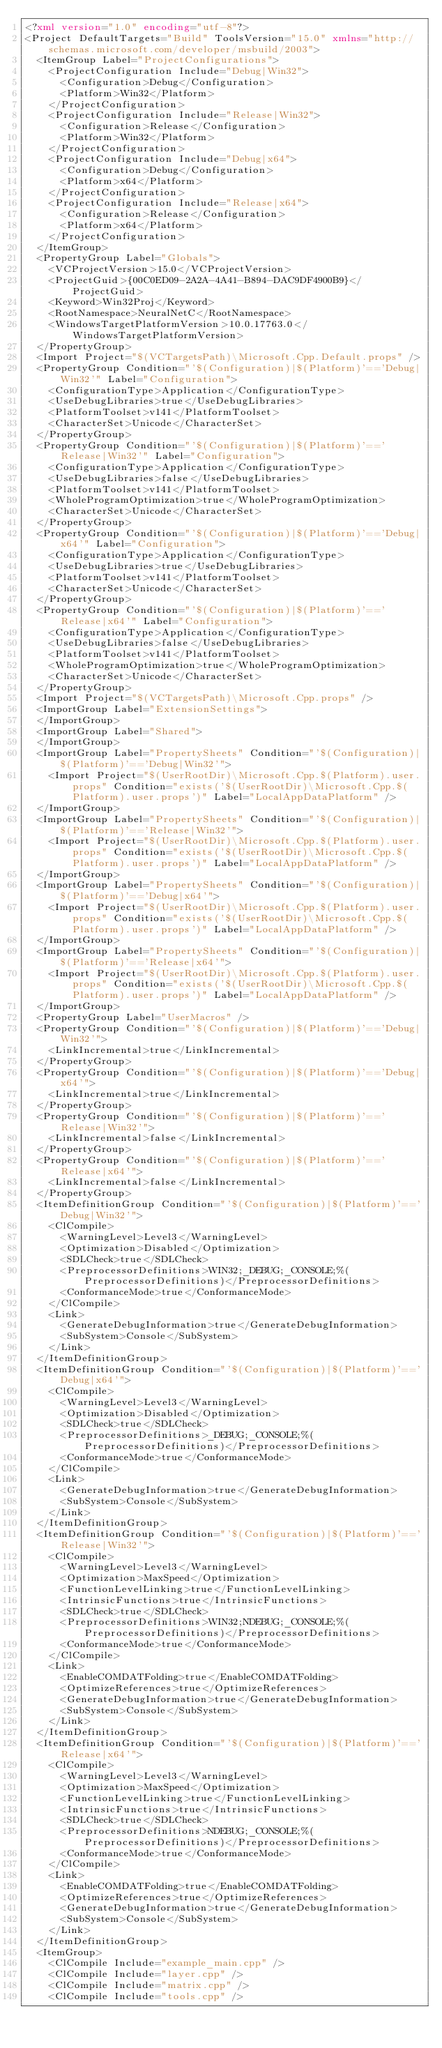<code> <loc_0><loc_0><loc_500><loc_500><_XML_><?xml version="1.0" encoding="utf-8"?>
<Project DefaultTargets="Build" ToolsVersion="15.0" xmlns="http://schemas.microsoft.com/developer/msbuild/2003">
  <ItemGroup Label="ProjectConfigurations">
    <ProjectConfiguration Include="Debug|Win32">
      <Configuration>Debug</Configuration>
      <Platform>Win32</Platform>
    </ProjectConfiguration>
    <ProjectConfiguration Include="Release|Win32">
      <Configuration>Release</Configuration>
      <Platform>Win32</Platform>
    </ProjectConfiguration>
    <ProjectConfiguration Include="Debug|x64">
      <Configuration>Debug</Configuration>
      <Platform>x64</Platform>
    </ProjectConfiguration>
    <ProjectConfiguration Include="Release|x64">
      <Configuration>Release</Configuration>
      <Platform>x64</Platform>
    </ProjectConfiguration>
  </ItemGroup>
  <PropertyGroup Label="Globals">
    <VCProjectVersion>15.0</VCProjectVersion>
    <ProjectGuid>{00C0ED09-2A2A-4A41-B894-DAC9DF4900B9}</ProjectGuid>
    <Keyword>Win32Proj</Keyword>
    <RootNamespace>NeuralNetC</RootNamespace>
    <WindowsTargetPlatformVersion>10.0.17763.0</WindowsTargetPlatformVersion>
  </PropertyGroup>
  <Import Project="$(VCTargetsPath)\Microsoft.Cpp.Default.props" />
  <PropertyGroup Condition="'$(Configuration)|$(Platform)'=='Debug|Win32'" Label="Configuration">
    <ConfigurationType>Application</ConfigurationType>
    <UseDebugLibraries>true</UseDebugLibraries>
    <PlatformToolset>v141</PlatformToolset>
    <CharacterSet>Unicode</CharacterSet>
  </PropertyGroup>
  <PropertyGroup Condition="'$(Configuration)|$(Platform)'=='Release|Win32'" Label="Configuration">
    <ConfigurationType>Application</ConfigurationType>
    <UseDebugLibraries>false</UseDebugLibraries>
    <PlatformToolset>v141</PlatformToolset>
    <WholeProgramOptimization>true</WholeProgramOptimization>
    <CharacterSet>Unicode</CharacterSet>
  </PropertyGroup>
  <PropertyGroup Condition="'$(Configuration)|$(Platform)'=='Debug|x64'" Label="Configuration">
    <ConfigurationType>Application</ConfigurationType>
    <UseDebugLibraries>true</UseDebugLibraries>
    <PlatformToolset>v141</PlatformToolset>
    <CharacterSet>Unicode</CharacterSet>
  </PropertyGroup>
  <PropertyGroup Condition="'$(Configuration)|$(Platform)'=='Release|x64'" Label="Configuration">
    <ConfigurationType>Application</ConfigurationType>
    <UseDebugLibraries>false</UseDebugLibraries>
    <PlatformToolset>v141</PlatformToolset>
    <WholeProgramOptimization>true</WholeProgramOptimization>
    <CharacterSet>Unicode</CharacterSet>
  </PropertyGroup>
  <Import Project="$(VCTargetsPath)\Microsoft.Cpp.props" />
  <ImportGroup Label="ExtensionSettings">
  </ImportGroup>
  <ImportGroup Label="Shared">
  </ImportGroup>
  <ImportGroup Label="PropertySheets" Condition="'$(Configuration)|$(Platform)'=='Debug|Win32'">
    <Import Project="$(UserRootDir)\Microsoft.Cpp.$(Platform).user.props" Condition="exists('$(UserRootDir)\Microsoft.Cpp.$(Platform).user.props')" Label="LocalAppDataPlatform" />
  </ImportGroup>
  <ImportGroup Label="PropertySheets" Condition="'$(Configuration)|$(Platform)'=='Release|Win32'">
    <Import Project="$(UserRootDir)\Microsoft.Cpp.$(Platform).user.props" Condition="exists('$(UserRootDir)\Microsoft.Cpp.$(Platform).user.props')" Label="LocalAppDataPlatform" />
  </ImportGroup>
  <ImportGroup Label="PropertySheets" Condition="'$(Configuration)|$(Platform)'=='Debug|x64'">
    <Import Project="$(UserRootDir)\Microsoft.Cpp.$(Platform).user.props" Condition="exists('$(UserRootDir)\Microsoft.Cpp.$(Platform).user.props')" Label="LocalAppDataPlatform" />
  </ImportGroup>
  <ImportGroup Label="PropertySheets" Condition="'$(Configuration)|$(Platform)'=='Release|x64'">
    <Import Project="$(UserRootDir)\Microsoft.Cpp.$(Platform).user.props" Condition="exists('$(UserRootDir)\Microsoft.Cpp.$(Platform).user.props')" Label="LocalAppDataPlatform" />
  </ImportGroup>
  <PropertyGroup Label="UserMacros" />
  <PropertyGroup Condition="'$(Configuration)|$(Platform)'=='Debug|Win32'">
    <LinkIncremental>true</LinkIncremental>
  </PropertyGroup>
  <PropertyGroup Condition="'$(Configuration)|$(Platform)'=='Debug|x64'">
    <LinkIncremental>true</LinkIncremental>
  </PropertyGroup>
  <PropertyGroup Condition="'$(Configuration)|$(Platform)'=='Release|Win32'">
    <LinkIncremental>false</LinkIncremental>
  </PropertyGroup>
  <PropertyGroup Condition="'$(Configuration)|$(Platform)'=='Release|x64'">
    <LinkIncremental>false</LinkIncremental>
  </PropertyGroup>
  <ItemDefinitionGroup Condition="'$(Configuration)|$(Platform)'=='Debug|Win32'">
    <ClCompile>
      <WarningLevel>Level3</WarningLevel>
      <Optimization>Disabled</Optimization>
      <SDLCheck>true</SDLCheck>
      <PreprocessorDefinitions>WIN32;_DEBUG;_CONSOLE;%(PreprocessorDefinitions)</PreprocessorDefinitions>
      <ConformanceMode>true</ConformanceMode>
    </ClCompile>
    <Link>
      <GenerateDebugInformation>true</GenerateDebugInformation>
      <SubSystem>Console</SubSystem>
    </Link>
  </ItemDefinitionGroup>
  <ItemDefinitionGroup Condition="'$(Configuration)|$(Platform)'=='Debug|x64'">
    <ClCompile>
      <WarningLevel>Level3</WarningLevel>
      <Optimization>Disabled</Optimization>
      <SDLCheck>true</SDLCheck>
      <PreprocessorDefinitions>_DEBUG;_CONSOLE;%(PreprocessorDefinitions)</PreprocessorDefinitions>
      <ConformanceMode>true</ConformanceMode>
    </ClCompile>
    <Link>
      <GenerateDebugInformation>true</GenerateDebugInformation>
      <SubSystem>Console</SubSystem>
    </Link>
  </ItemDefinitionGroup>
  <ItemDefinitionGroup Condition="'$(Configuration)|$(Platform)'=='Release|Win32'">
    <ClCompile>
      <WarningLevel>Level3</WarningLevel>
      <Optimization>MaxSpeed</Optimization>
      <FunctionLevelLinking>true</FunctionLevelLinking>
      <IntrinsicFunctions>true</IntrinsicFunctions>
      <SDLCheck>true</SDLCheck>
      <PreprocessorDefinitions>WIN32;NDEBUG;_CONSOLE;%(PreprocessorDefinitions)</PreprocessorDefinitions>
      <ConformanceMode>true</ConformanceMode>
    </ClCompile>
    <Link>
      <EnableCOMDATFolding>true</EnableCOMDATFolding>
      <OptimizeReferences>true</OptimizeReferences>
      <GenerateDebugInformation>true</GenerateDebugInformation>
      <SubSystem>Console</SubSystem>
    </Link>
  </ItemDefinitionGroup>
  <ItemDefinitionGroup Condition="'$(Configuration)|$(Platform)'=='Release|x64'">
    <ClCompile>
      <WarningLevel>Level3</WarningLevel>
      <Optimization>MaxSpeed</Optimization>
      <FunctionLevelLinking>true</FunctionLevelLinking>
      <IntrinsicFunctions>true</IntrinsicFunctions>
      <SDLCheck>true</SDLCheck>
      <PreprocessorDefinitions>NDEBUG;_CONSOLE;%(PreprocessorDefinitions)</PreprocessorDefinitions>
      <ConformanceMode>true</ConformanceMode>
    </ClCompile>
    <Link>
      <EnableCOMDATFolding>true</EnableCOMDATFolding>
      <OptimizeReferences>true</OptimizeReferences>
      <GenerateDebugInformation>true</GenerateDebugInformation>
      <SubSystem>Console</SubSystem>
    </Link>
  </ItemDefinitionGroup>
  <ItemGroup>
    <ClCompile Include="example_main.cpp" />
    <ClCompile Include="layer.cpp" />
    <ClCompile Include="matrix.cpp" />
    <ClCompile Include="tools.cpp" /></code> 